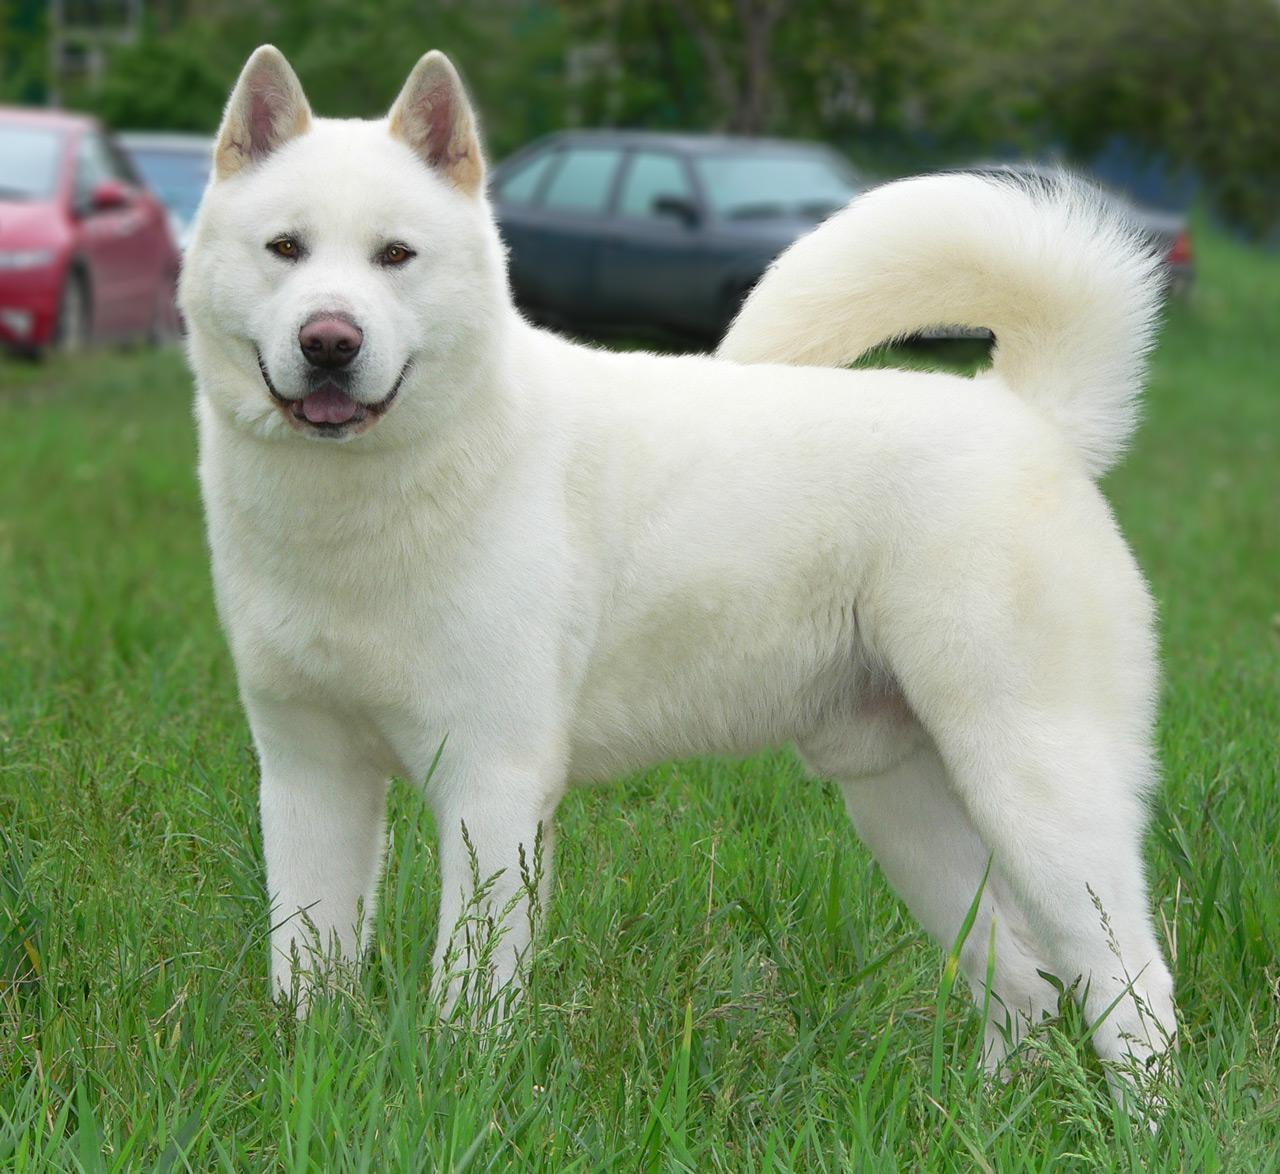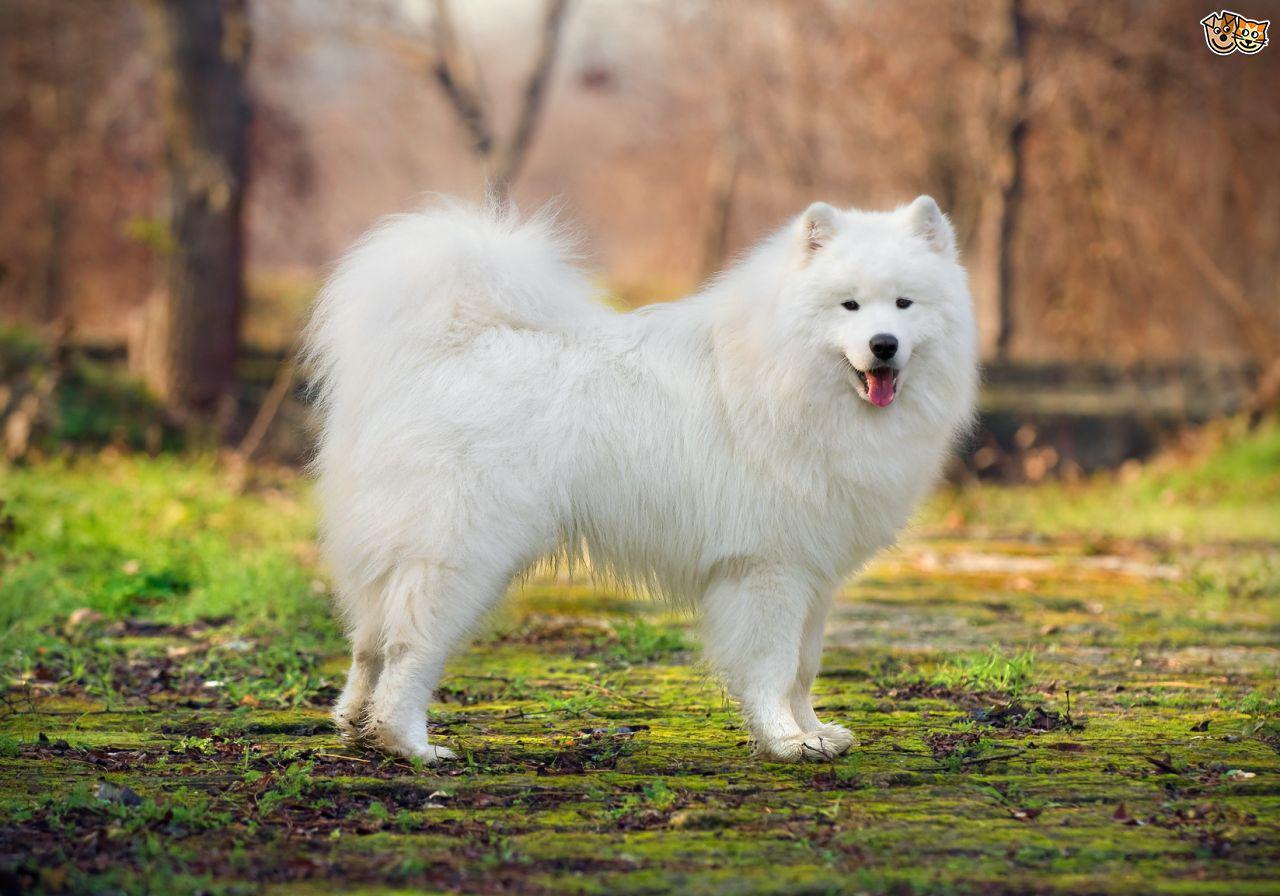The first image is the image on the left, the second image is the image on the right. Assess this claim about the two images: "One dog is facing the right and one dog is facing the left.". Correct or not? Answer yes or no. Yes. 